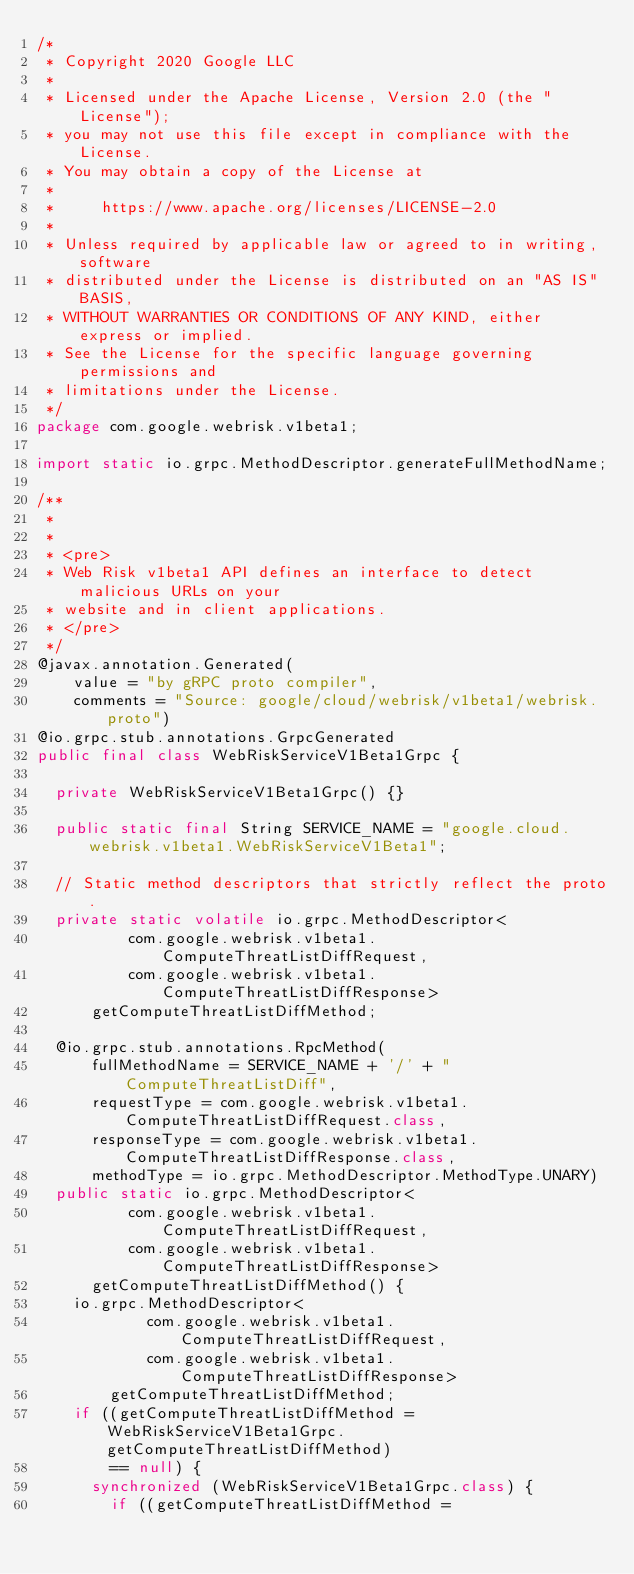<code> <loc_0><loc_0><loc_500><loc_500><_Java_>/*
 * Copyright 2020 Google LLC
 *
 * Licensed under the Apache License, Version 2.0 (the "License");
 * you may not use this file except in compliance with the License.
 * You may obtain a copy of the License at
 *
 *     https://www.apache.org/licenses/LICENSE-2.0
 *
 * Unless required by applicable law or agreed to in writing, software
 * distributed under the License is distributed on an "AS IS" BASIS,
 * WITHOUT WARRANTIES OR CONDITIONS OF ANY KIND, either express or implied.
 * See the License for the specific language governing permissions and
 * limitations under the License.
 */
package com.google.webrisk.v1beta1;

import static io.grpc.MethodDescriptor.generateFullMethodName;

/**
 *
 *
 * <pre>
 * Web Risk v1beta1 API defines an interface to detect malicious URLs on your
 * website and in client applications.
 * </pre>
 */
@javax.annotation.Generated(
    value = "by gRPC proto compiler",
    comments = "Source: google/cloud/webrisk/v1beta1/webrisk.proto")
@io.grpc.stub.annotations.GrpcGenerated
public final class WebRiskServiceV1Beta1Grpc {

  private WebRiskServiceV1Beta1Grpc() {}

  public static final String SERVICE_NAME = "google.cloud.webrisk.v1beta1.WebRiskServiceV1Beta1";

  // Static method descriptors that strictly reflect the proto.
  private static volatile io.grpc.MethodDescriptor<
          com.google.webrisk.v1beta1.ComputeThreatListDiffRequest,
          com.google.webrisk.v1beta1.ComputeThreatListDiffResponse>
      getComputeThreatListDiffMethod;

  @io.grpc.stub.annotations.RpcMethod(
      fullMethodName = SERVICE_NAME + '/' + "ComputeThreatListDiff",
      requestType = com.google.webrisk.v1beta1.ComputeThreatListDiffRequest.class,
      responseType = com.google.webrisk.v1beta1.ComputeThreatListDiffResponse.class,
      methodType = io.grpc.MethodDescriptor.MethodType.UNARY)
  public static io.grpc.MethodDescriptor<
          com.google.webrisk.v1beta1.ComputeThreatListDiffRequest,
          com.google.webrisk.v1beta1.ComputeThreatListDiffResponse>
      getComputeThreatListDiffMethod() {
    io.grpc.MethodDescriptor<
            com.google.webrisk.v1beta1.ComputeThreatListDiffRequest,
            com.google.webrisk.v1beta1.ComputeThreatListDiffResponse>
        getComputeThreatListDiffMethod;
    if ((getComputeThreatListDiffMethod = WebRiskServiceV1Beta1Grpc.getComputeThreatListDiffMethod)
        == null) {
      synchronized (WebRiskServiceV1Beta1Grpc.class) {
        if ((getComputeThreatListDiffMethod =</code> 